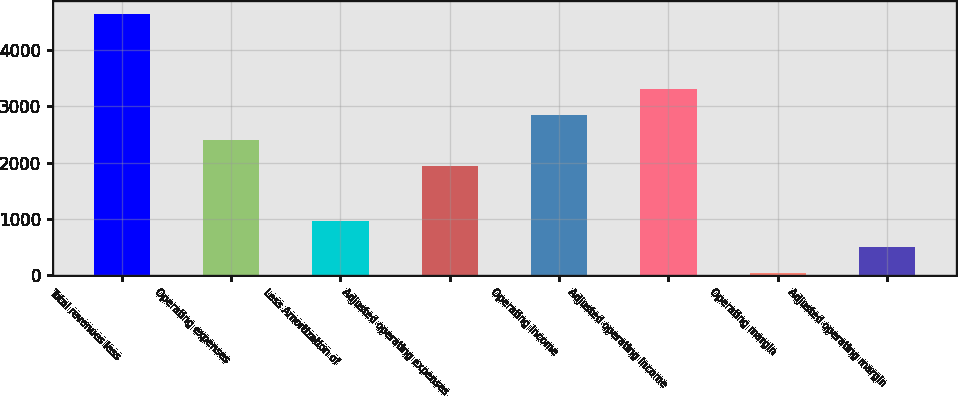Convert chart to OTSL. <chart><loc_0><loc_0><loc_500><loc_500><bar_chart><fcel>Total revenues less<fcel>Operating expenses<fcel>Less Amortization of<fcel>Adjusted operating expenses<fcel>Operating income<fcel>Adjusted operating income<fcel>Operating margin<fcel>Adjusted operating margin<nl><fcel>4629<fcel>2395.8<fcel>966.6<fcel>1938<fcel>2853.6<fcel>3311.4<fcel>51<fcel>508.8<nl></chart> 